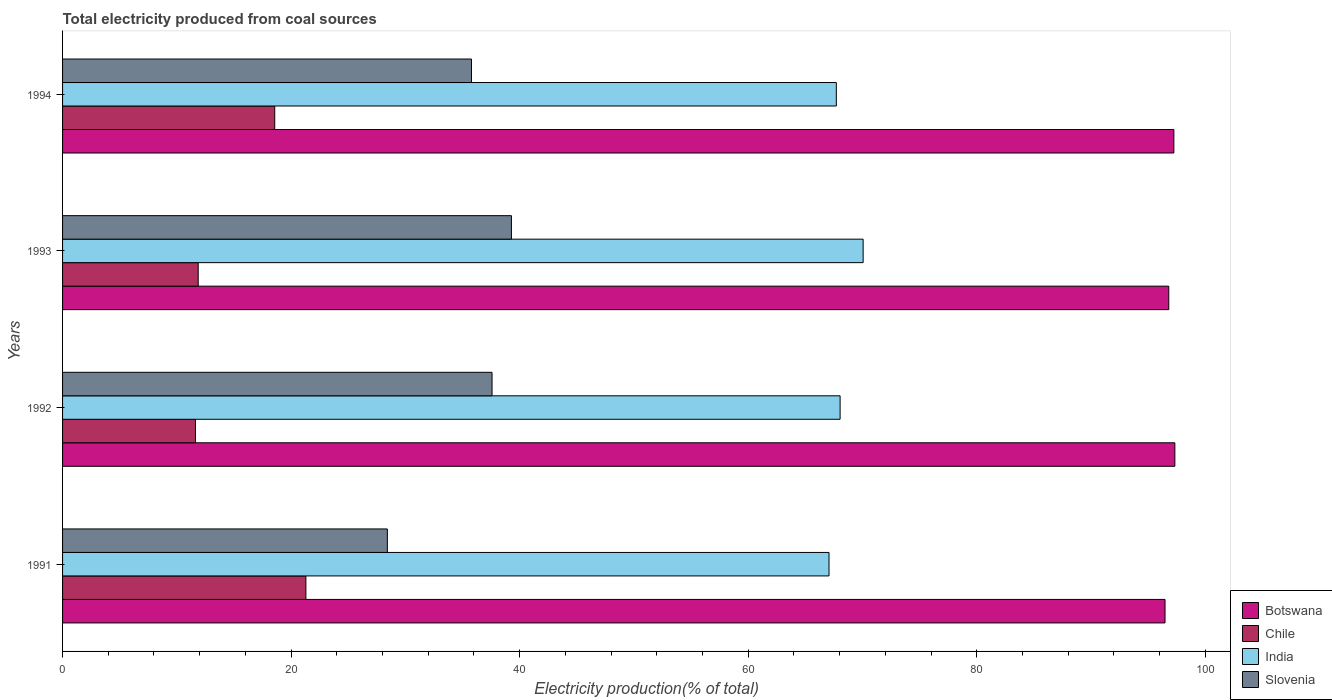How many different coloured bars are there?
Make the answer very short. 4. Are the number of bars on each tick of the Y-axis equal?
Your answer should be very brief. Yes. How many bars are there on the 1st tick from the top?
Make the answer very short. 4. What is the label of the 3rd group of bars from the top?
Your answer should be compact. 1992. In how many cases, is the number of bars for a given year not equal to the number of legend labels?
Keep it short and to the point. 0. What is the total electricity produced in India in 1993?
Keep it short and to the point. 70.05. Across all years, what is the maximum total electricity produced in Slovenia?
Offer a very short reply. 39.28. Across all years, what is the minimum total electricity produced in Slovenia?
Ensure brevity in your answer.  28.42. What is the total total electricity produced in India in the graph?
Provide a succinct answer. 272.87. What is the difference between the total electricity produced in Chile in 1991 and that in 1993?
Your answer should be compact. 9.42. What is the difference between the total electricity produced in Slovenia in 1994 and the total electricity produced in Botswana in 1992?
Keep it short and to the point. -61.55. What is the average total electricity produced in India per year?
Your response must be concise. 68.22. In the year 1992, what is the difference between the total electricity produced in Slovenia and total electricity produced in Chile?
Ensure brevity in your answer.  25.95. What is the ratio of the total electricity produced in Slovenia in 1993 to that in 1994?
Keep it short and to the point. 1.1. Is the total electricity produced in Botswana in 1992 less than that in 1994?
Your answer should be very brief. No. Is the difference between the total electricity produced in Slovenia in 1991 and 1992 greater than the difference between the total electricity produced in Chile in 1991 and 1992?
Your answer should be compact. No. What is the difference between the highest and the second highest total electricity produced in Chile?
Ensure brevity in your answer.  2.73. What is the difference between the highest and the lowest total electricity produced in India?
Keep it short and to the point. 2.99. In how many years, is the total electricity produced in Slovenia greater than the average total electricity produced in Slovenia taken over all years?
Provide a succinct answer. 3. What does the 4th bar from the top in 1992 represents?
Provide a short and direct response. Botswana. Is it the case that in every year, the sum of the total electricity produced in Chile and total electricity produced in India is greater than the total electricity produced in Botswana?
Keep it short and to the point. No. How many bars are there?
Offer a terse response. 16. Are all the bars in the graph horizontal?
Ensure brevity in your answer.  Yes. What is the difference between two consecutive major ticks on the X-axis?
Your response must be concise. 20. Does the graph contain any zero values?
Your answer should be compact. No. Does the graph contain grids?
Your response must be concise. No. How are the legend labels stacked?
Provide a succinct answer. Vertical. What is the title of the graph?
Provide a short and direct response. Total electricity produced from coal sources. Does "Hungary" appear as one of the legend labels in the graph?
Your response must be concise. No. What is the label or title of the X-axis?
Give a very brief answer. Electricity production(% of total). What is the Electricity production(% of total) in Botswana in 1991?
Ensure brevity in your answer.  96.47. What is the Electricity production(% of total) of Chile in 1991?
Ensure brevity in your answer.  21.29. What is the Electricity production(% of total) in India in 1991?
Your response must be concise. 67.07. What is the Electricity production(% of total) in Slovenia in 1991?
Offer a very short reply. 28.42. What is the Electricity production(% of total) in Botswana in 1992?
Your response must be concise. 97.33. What is the Electricity production(% of total) of Chile in 1992?
Ensure brevity in your answer.  11.63. What is the Electricity production(% of total) in India in 1992?
Offer a terse response. 68.04. What is the Electricity production(% of total) of Slovenia in 1992?
Make the answer very short. 37.58. What is the Electricity production(% of total) of Botswana in 1993?
Offer a terse response. 96.8. What is the Electricity production(% of total) in Chile in 1993?
Offer a very short reply. 11.87. What is the Electricity production(% of total) in India in 1993?
Give a very brief answer. 70.05. What is the Electricity production(% of total) of Slovenia in 1993?
Ensure brevity in your answer.  39.28. What is the Electricity production(% of total) of Botswana in 1994?
Keep it short and to the point. 97.24. What is the Electricity production(% of total) in Chile in 1994?
Give a very brief answer. 18.57. What is the Electricity production(% of total) in India in 1994?
Give a very brief answer. 67.71. What is the Electricity production(% of total) of Slovenia in 1994?
Ensure brevity in your answer.  35.78. Across all years, what is the maximum Electricity production(% of total) in Botswana?
Provide a succinct answer. 97.33. Across all years, what is the maximum Electricity production(% of total) in Chile?
Your response must be concise. 21.29. Across all years, what is the maximum Electricity production(% of total) in India?
Make the answer very short. 70.05. Across all years, what is the maximum Electricity production(% of total) of Slovenia?
Your response must be concise. 39.28. Across all years, what is the minimum Electricity production(% of total) in Botswana?
Ensure brevity in your answer.  96.47. Across all years, what is the minimum Electricity production(% of total) in Chile?
Make the answer very short. 11.63. Across all years, what is the minimum Electricity production(% of total) in India?
Offer a terse response. 67.07. Across all years, what is the minimum Electricity production(% of total) in Slovenia?
Provide a succinct answer. 28.42. What is the total Electricity production(% of total) of Botswana in the graph?
Your answer should be very brief. 387.84. What is the total Electricity production(% of total) in Chile in the graph?
Offer a very short reply. 63.36. What is the total Electricity production(% of total) in India in the graph?
Your answer should be compact. 272.87. What is the total Electricity production(% of total) of Slovenia in the graph?
Your answer should be very brief. 141.06. What is the difference between the Electricity production(% of total) of Botswana in 1991 and that in 1992?
Keep it short and to the point. -0.86. What is the difference between the Electricity production(% of total) of Chile in 1991 and that in 1992?
Offer a terse response. 9.66. What is the difference between the Electricity production(% of total) in India in 1991 and that in 1992?
Provide a short and direct response. -0.97. What is the difference between the Electricity production(% of total) of Slovenia in 1991 and that in 1992?
Offer a very short reply. -9.16. What is the difference between the Electricity production(% of total) of Botswana in 1991 and that in 1993?
Give a very brief answer. -0.33. What is the difference between the Electricity production(% of total) of Chile in 1991 and that in 1993?
Your response must be concise. 9.42. What is the difference between the Electricity production(% of total) in India in 1991 and that in 1993?
Your response must be concise. -2.99. What is the difference between the Electricity production(% of total) of Slovenia in 1991 and that in 1993?
Make the answer very short. -10.86. What is the difference between the Electricity production(% of total) of Botswana in 1991 and that in 1994?
Offer a terse response. -0.77. What is the difference between the Electricity production(% of total) of Chile in 1991 and that in 1994?
Your answer should be very brief. 2.73. What is the difference between the Electricity production(% of total) of India in 1991 and that in 1994?
Give a very brief answer. -0.64. What is the difference between the Electricity production(% of total) of Slovenia in 1991 and that in 1994?
Offer a very short reply. -7.36. What is the difference between the Electricity production(% of total) in Botswana in 1992 and that in 1993?
Provide a short and direct response. 0.53. What is the difference between the Electricity production(% of total) in Chile in 1992 and that in 1993?
Your answer should be compact. -0.24. What is the difference between the Electricity production(% of total) of India in 1992 and that in 1993?
Offer a terse response. -2.01. What is the difference between the Electricity production(% of total) of Slovenia in 1992 and that in 1993?
Provide a succinct answer. -1.7. What is the difference between the Electricity production(% of total) of Botswana in 1992 and that in 1994?
Keep it short and to the point. 0.09. What is the difference between the Electricity production(% of total) in Chile in 1992 and that in 1994?
Your answer should be compact. -6.94. What is the difference between the Electricity production(% of total) of India in 1992 and that in 1994?
Provide a succinct answer. 0.33. What is the difference between the Electricity production(% of total) in Slovenia in 1992 and that in 1994?
Ensure brevity in your answer.  1.8. What is the difference between the Electricity production(% of total) in Botswana in 1993 and that in 1994?
Your answer should be compact. -0.45. What is the difference between the Electricity production(% of total) of Chile in 1993 and that in 1994?
Your response must be concise. -6.7. What is the difference between the Electricity production(% of total) of India in 1993 and that in 1994?
Offer a very short reply. 2.35. What is the difference between the Electricity production(% of total) of Slovenia in 1993 and that in 1994?
Your answer should be very brief. 3.5. What is the difference between the Electricity production(% of total) of Botswana in 1991 and the Electricity production(% of total) of Chile in 1992?
Give a very brief answer. 84.84. What is the difference between the Electricity production(% of total) of Botswana in 1991 and the Electricity production(% of total) of India in 1992?
Provide a succinct answer. 28.43. What is the difference between the Electricity production(% of total) in Botswana in 1991 and the Electricity production(% of total) in Slovenia in 1992?
Ensure brevity in your answer.  58.89. What is the difference between the Electricity production(% of total) in Chile in 1991 and the Electricity production(% of total) in India in 1992?
Make the answer very short. -46.75. What is the difference between the Electricity production(% of total) in Chile in 1991 and the Electricity production(% of total) in Slovenia in 1992?
Your answer should be compact. -16.29. What is the difference between the Electricity production(% of total) in India in 1991 and the Electricity production(% of total) in Slovenia in 1992?
Your response must be concise. 29.49. What is the difference between the Electricity production(% of total) in Botswana in 1991 and the Electricity production(% of total) in Chile in 1993?
Offer a very short reply. 84.6. What is the difference between the Electricity production(% of total) in Botswana in 1991 and the Electricity production(% of total) in India in 1993?
Offer a very short reply. 26.42. What is the difference between the Electricity production(% of total) in Botswana in 1991 and the Electricity production(% of total) in Slovenia in 1993?
Provide a succinct answer. 57.19. What is the difference between the Electricity production(% of total) in Chile in 1991 and the Electricity production(% of total) in India in 1993?
Your answer should be very brief. -48.76. What is the difference between the Electricity production(% of total) in Chile in 1991 and the Electricity production(% of total) in Slovenia in 1993?
Provide a short and direct response. -17.99. What is the difference between the Electricity production(% of total) of India in 1991 and the Electricity production(% of total) of Slovenia in 1993?
Your response must be concise. 27.79. What is the difference between the Electricity production(% of total) of Botswana in 1991 and the Electricity production(% of total) of Chile in 1994?
Offer a terse response. 77.9. What is the difference between the Electricity production(% of total) of Botswana in 1991 and the Electricity production(% of total) of India in 1994?
Your answer should be compact. 28.76. What is the difference between the Electricity production(% of total) of Botswana in 1991 and the Electricity production(% of total) of Slovenia in 1994?
Provide a short and direct response. 60.69. What is the difference between the Electricity production(% of total) in Chile in 1991 and the Electricity production(% of total) in India in 1994?
Offer a terse response. -46.42. What is the difference between the Electricity production(% of total) in Chile in 1991 and the Electricity production(% of total) in Slovenia in 1994?
Your answer should be very brief. -14.49. What is the difference between the Electricity production(% of total) in India in 1991 and the Electricity production(% of total) in Slovenia in 1994?
Offer a terse response. 31.29. What is the difference between the Electricity production(% of total) of Botswana in 1992 and the Electricity production(% of total) of Chile in 1993?
Provide a succinct answer. 85.46. What is the difference between the Electricity production(% of total) of Botswana in 1992 and the Electricity production(% of total) of India in 1993?
Give a very brief answer. 27.28. What is the difference between the Electricity production(% of total) of Botswana in 1992 and the Electricity production(% of total) of Slovenia in 1993?
Offer a very short reply. 58.05. What is the difference between the Electricity production(% of total) in Chile in 1992 and the Electricity production(% of total) in India in 1993?
Offer a terse response. -58.42. What is the difference between the Electricity production(% of total) in Chile in 1992 and the Electricity production(% of total) in Slovenia in 1993?
Your answer should be compact. -27.65. What is the difference between the Electricity production(% of total) of India in 1992 and the Electricity production(% of total) of Slovenia in 1993?
Your answer should be very brief. 28.76. What is the difference between the Electricity production(% of total) in Botswana in 1992 and the Electricity production(% of total) in Chile in 1994?
Provide a short and direct response. 78.76. What is the difference between the Electricity production(% of total) in Botswana in 1992 and the Electricity production(% of total) in India in 1994?
Provide a succinct answer. 29.62. What is the difference between the Electricity production(% of total) in Botswana in 1992 and the Electricity production(% of total) in Slovenia in 1994?
Keep it short and to the point. 61.55. What is the difference between the Electricity production(% of total) in Chile in 1992 and the Electricity production(% of total) in India in 1994?
Your response must be concise. -56.08. What is the difference between the Electricity production(% of total) in Chile in 1992 and the Electricity production(% of total) in Slovenia in 1994?
Your answer should be compact. -24.15. What is the difference between the Electricity production(% of total) in India in 1992 and the Electricity production(% of total) in Slovenia in 1994?
Your answer should be compact. 32.26. What is the difference between the Electricity production(% of total) of Botswana in 1993 and the Electricity production(% of total) of Chile in 1994?
Offer a terse response. 78.23. What is the difference between the Electricity production(% of total) in Botswana in 1993 and the Electricity production(% of total) in India in 1994?
Your answer should be very brief. 29.09. What is the difference between the Electricity production(% of total) of Botswana in 1993 and the Electricity production(% of total) of Slovenia in 1994?
Offer a very short reply. 61.02. What is the difference between the Electricity production(% of total) in Chile in 1993 and the Electricity production(% of total) in India in 1994?
Keep it short and to the point. -55.84. What is the difference between the Electricity production(% of total) of Chile in 1993 and the Electricity production(% of total) of Slovenia in 1994?
Keep it short and to the point. -23.91. What is the difference between the Electricity production(% of total) of India in 1993 and the Electricity production(% of total) of Slovenia in 1994?
Ensure brevity in your answer.  34.27. What is the average Electricity production(% of total) in Botswana per year?
Provide a short and direct response. 96.96. What is the average Electricity production(% of total) in Chile per year?
Give a very brief answer. 15.84. What is the average Electricity production(% of total) in India per year?
Offer a terse response. 68.22. What is the average Electricity production(% of total) in Slovenia per year?
Ensure brevity in your answer.  35.27. In the year 1991, what is the difference between the Electricity production(% of total) in Botswana and Electricity production(% of total) in Chile?
Your response must be concise. 75.18. In the year 1991, what is the difference between the Electricity production(% of total) in Botswana and Electricity production(% of total) in India?
Your answer should be very brief. 29.4. In the year 1991, what is the difference between the Electricity production(% of total) of Botswana and Electricity production(% of total) of Slovenia?
Give a very brief answer. 68.05. In the year 1991, what is the difference between the Electricity production(% of total) of Chile and Electricity production(% of total) of India?
Ensure brevity in your answer.  -45.78. In the year 1991, what is the difference between the Electricity production(% of total) in Chile and Electricity production(% of total) in Slovenia?
Give a very brief answer. -7.13. In the year 1991, what is the difference between the Electricity production(% of total) of India and Electricity production(% of total) of Slovenia?
Make the answer very short. 38.65. In the year 1992, what is the difference between the Electricity production(% of total) of Botswana and Electricity production(% of total) of Chile?
Ensure brevity in your answer.  85.7. In the year 1992, what is the difference between the Electricity production(% of total) of Botswana and Electricity production(% of total) of India?
Your answer should be very brief. 29.29. In the year 1992, what is the difference between the Electricity production(% of total) of Botswana and Electricity production(% of total) of Slovenia?
Ensure brevity in your answer.  59.75. In the year 1992, what is the difference between the Electricity production(% of total) in Chile and Electricity production(% of total) in India?
Offer a very short reply. -56.41. In the year 1992, what is the difference between the Electricity production(% of total) in Chile and Electricity production(% of total) in Slovenia?
Give a very brief answer. -25.95. In the year 1992, what is the difference between the Electricity production(% of total) in India and Electricity production(% of total) in Slovenia?
Make the answer very short. 30.46. In the year 1993, what is the difference between the Electricity production(% of total) of Botswana and Electricity production(% of total) of Chile?
Offer a terse response. 84.93. In the year 1993, what is the difference between the Electricity production(% of total) of Botswana and Electricity production(% of total) of India?
Make the answer very short. 26.74. In the year 1993, what is the difference between the Electricity production(% of total) of Botswana and Electricity production(% of total) of Slovenia?
Ensure brevity in your answer.  57.52. In the year 1993, what is the difference between the Electricity production(% of total) of Chile and Electricity production(% of total) of India?
Make the answer very short. -58.18. In the year 1993, what is the difference between the Electricity production(% of total) of Chile and Electricity production(% of total) of Slovenia?
Make the answer very short. -27.41. In the year 1993, what is the difference between the Electricity production(% of total) in India and Electricity production(% of total) in Slovenia?
Your response must be concise. 30.78. In the year 1994, what is the difference between the Electricity production(% of total) of Botswana and Electricity production(% of total) of Chile?
Offer a terse response. 78.68. In the year 1994, what is the difference between the Electricity production(% of total) in Botswana and Electricity production(% of total) in India?
Keep it short and to the point. 29.54. In the year 1994, what is the difference between the Electricity production(% of total) in Botswana and Electricity production(% of total) in Slovenia?
Ensure brevity in your answer.  61.46. In the year 1994, what is the difference between the Electricity production(% of total) in Chile and Electricity production(% of total) in India?
Offer a very short reply. -49.14. In the year 1994, what is the difference between the Electricity production(% of total) of Chile and Electricity production(% of total) of Slovenia?
Your answer should be compact. -17.21. In the year 1994, what is the difference between the Electricity production(% of total) in India and Electricity production(% of total) in Slovenia?
Your response must be concise. 31.93. What is the ratio of the Electricity production(% of total) of Botswana in 1991 to that in 1992?
Provide a short and direct response. 0.99. What is the ratio of the Electricity production(% of total) of Chile in 1991 to that in 1992?
Provide a short and direct response. 1.83. What is the ratio of the Electricity production(% of total) of India in 1991 to that in 1992?
Ensure brevity in your answer.  0.99. What is the ratio of the Electricity production(% of total) of Slovenia in 1991 to that in 1992?
Provide a short and direct response. 0.76. What is the ratio of the Electricity production(% of total) of Chile in 1991 to that in 1993?
Provide a succinct answer. 1.79. What is the ratio of the Electricity production(% of total) of India in 1991 to that in 1993?
Your answer should be very brief. 0.96. What is the ratio of the Electricity production(% of total) of Slovenia in 1991 to that in 1993?
Provide a short and direct response. 0.72. What is the ratio of the Electricity production(% of total) of Botswana in 1991 to that in 1994?
Give a very brief answer. 0.99. What is the ratio of the Electricity production(% of total) in Chile in 1991 to that in 1994?
Keep it short and to the point. 1.15. What is the ratio of the Electricity production(% of total) of India in 1991 to that in 1994?
Offer a terse response. 0.99. What is the ratio of the Electricity production(% of total) in Slovenia in 1991 to that in 1994?
Offer a terse response. 0.79. What is the ratio of the Electricity production(% of total) in Botswana in 1992 to that in 1993?
Provide a succinct answer. 1.01. What is the ratio of the Electricity production(% of total) in Chile in 1992 to that in 1993?
Make the answer very short. 0.98. What is the ratio of the Electricity production(% of total) in India in 1992 to that in 1993?
Your answer should be very brief. 0.97. What is the ratio of the Electricity production(% of total) in Slovenia in 1992 to that in 1993?
Provide a short and direct response. 0.96. What is the ratio of the Electricity production(% of total) of Chile in 1992 to that in 1994?
Give a very brief answer. 0.63. What is the ratio of the Electricity production(% of total) in India in 1992 to that in 1994?
Your answer should be very brief. 1. What is the ratio of the Electricity production(% of total) in Slovenia in 1992 to that in 1994?
Your answer should be compact. 1.05. What is the ratio of the Electricity production(% of total) in Chile in 1993 to that in 1994?
Your answer should be compact. 0.64. What is the ratio of the Electricity production(% of total) in India in 1993 to that in 1994?
Your answer should be compact. 1.03. What is the ratio of the Electricity production(% of total) in Slovenia in 1993 to that in 1994?
Your answer should be very brief. 1.1. What is the difference between the highest and the second highest Electricity production(% of total) in Botswana?
Make the answer very short. 0.09. What is the difference between the highest and the second highest Electricity production(% of total) of Chile?
Your answer should be very brief. 2.73. What is the difference between the highest and the second highest Electricity production(% of total) in India?
Ensure brevity in your answer.  2.01. What is the difference between the highest and the second highest Electricity production(% of total) in Slovenia?
Offer a very short reply. 1.7. What is the difference between the highest and the lowest Electricity production(% of total) in Botswana?
Keep it short and to the point. 0.86. What is the difference between the highest and the lowest Electricity production(% of total) of Chile?
Ensure brevity in your answer.  9.66. What is the difference between the highest and the lowest Electricity production(% of total) in India?
Offer a very short reply. 2.99. What is the difference between the highest and the lowest Electricity production(% of total) in Slovenia?
Offer a very short reply. 10.86. 